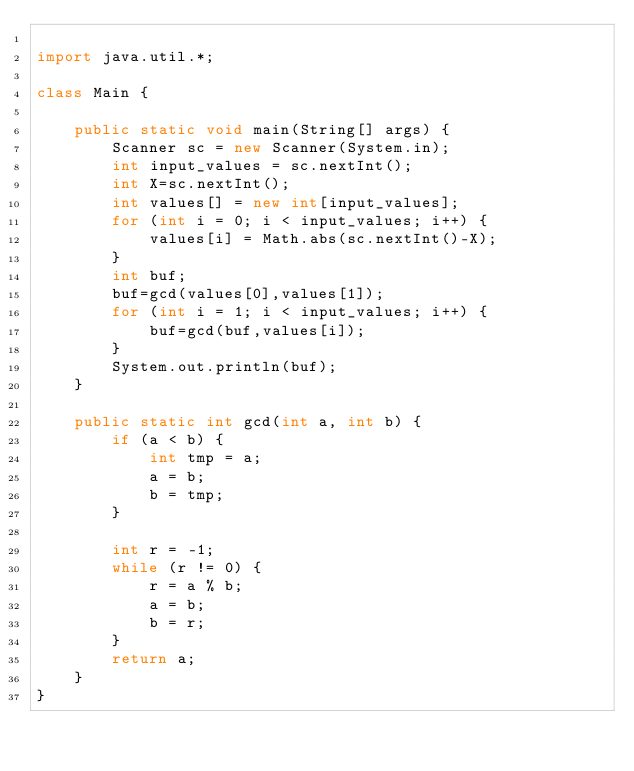Convert code to text. <code><loc_0><loc_0><loc_500><loc_500><_Java_>
import java.util.*;

class Main {

    public static void main(String[] args) {
        Scanner sc = new Scanner(System.in);
        int input_values = sc.nextInt();
        int X=sc.nextInt();
        int values[] = new int[input_values];
        for (int i = 0; i < input_values; i++) {
            values[i] = Math.abs(sc.nextInt()-X);
        }
        int buf;
        buf=gcd(values[0],values[1]);
        for (int i = 1; i < input_values; i++) {
            buf=gcd(buf,values[i]);
        }
        System.out.println(buf);
    }

    public static int gcd(int a, int b) {
        if (a < b) {
            int tmp = a;
            a = b;
            b = tmp;
        }

        int r = -1;
        while (r != 0) {
            r = a % b;
            a = b;
            b = r;
        }
        return a;
    }
}
</code> 